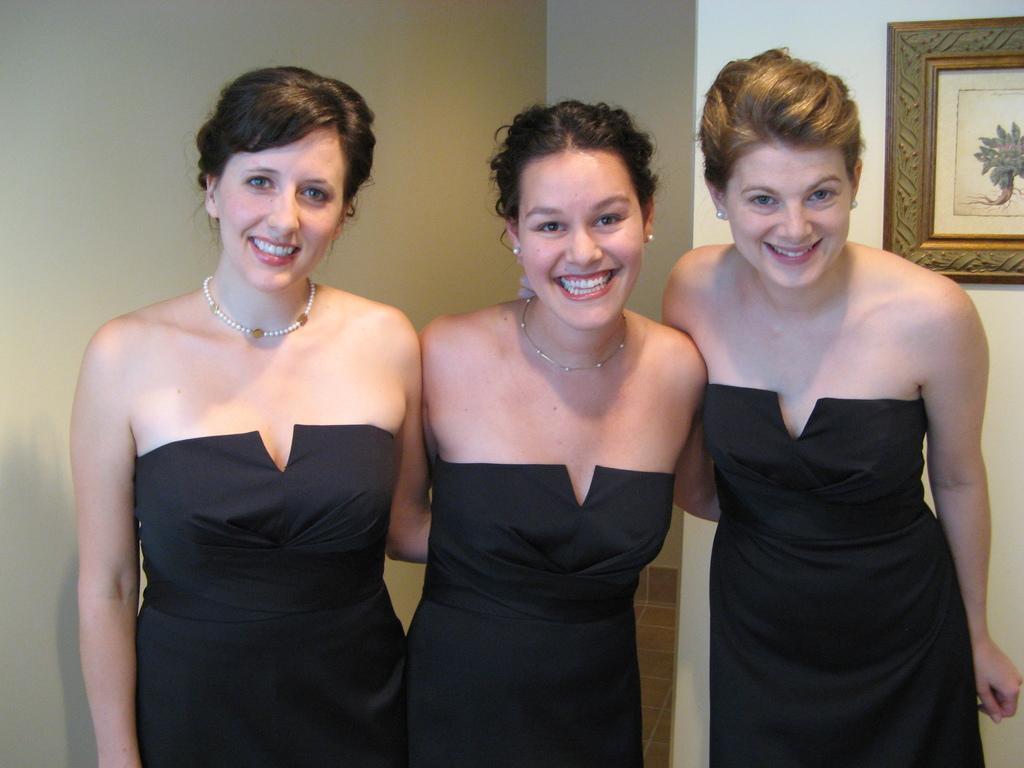Can you describe this image briefly? In this image we can see women standing on the floor. In the background there is a wall and photo frame. 